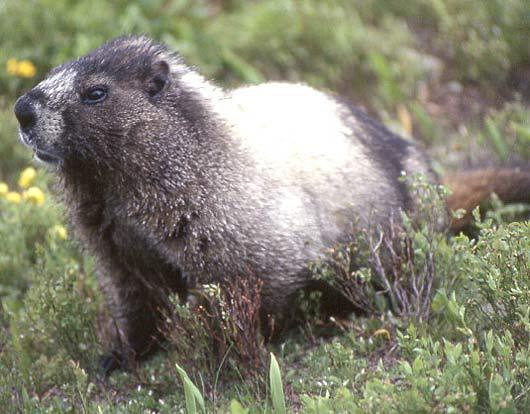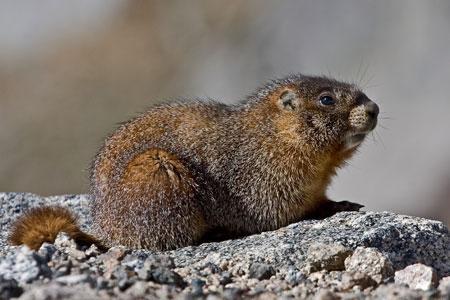The first image is the image on the left, the second image is the image on the right. Assess this claim about the two images: "The animal is facing left in the left image and right in the right image.". Correct or not? Answer yes or no. Yes. 